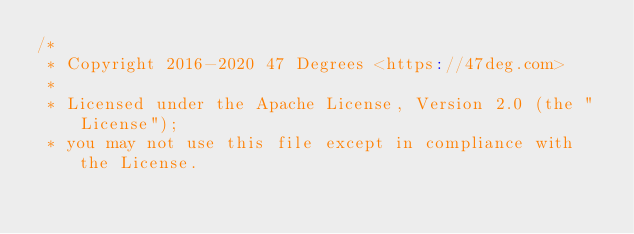Convert code to text. <code><loc_0><loc_0><loc_500><loc_500><_Scala_>/*
 * Copyright 2016-2020 47 Degrees <https://47deg.com>
 *
 * Licensed under the Apache License, Version 2.0 (the "License");
 * you may not use this file except in compliance with the License.</code> 